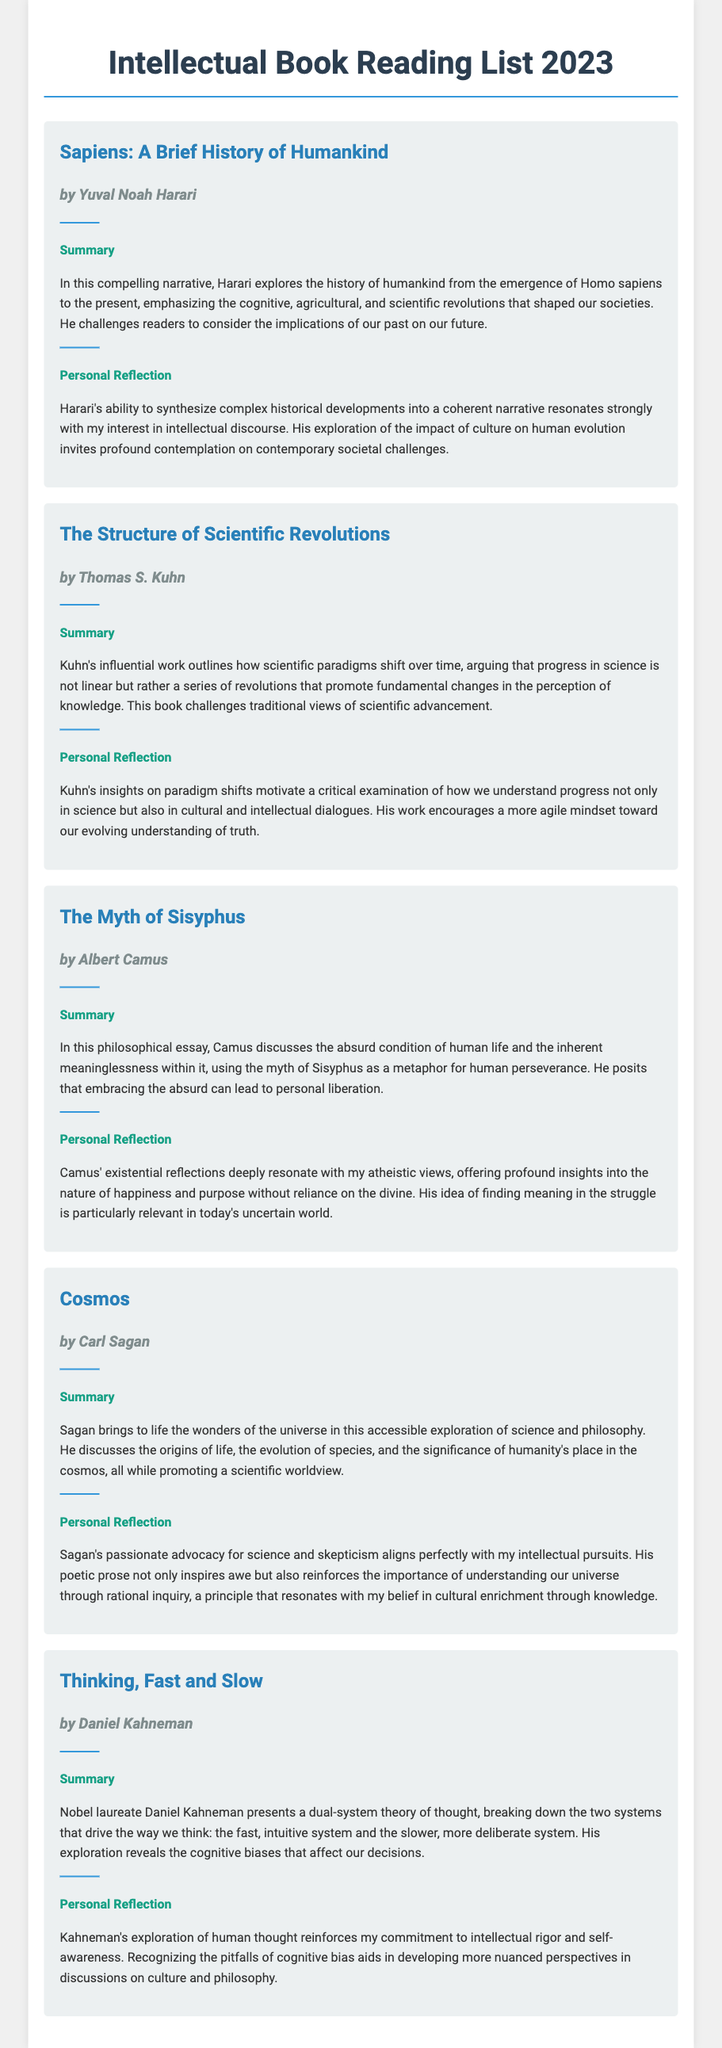What is the title of the first book? The title of the first book is the name stated in the document under the first book section.
Answer: Sapiens: A Brief History of Humankind Who is the author of "The Structure of Scientific Revolutions"? The author's name is provided in conjunction with the book title in the document.
Answer: Thomas S. Kuhn How many books are listed in the reading list? The number of books can be counted based on the sections present in the document.
Answer: 5 Which book discusses the absurd condition of human life? The content relates to the analysis provided in the summary of one of the book sections.
Answer: The Myth of Sisyphus What is the primary focus of "Cosmos"? The document explains the main themes and subjects discussed in the book summary.
Answer: Wonders of the universe What type of worldview does Carl Sagan promote in "Cosmos"? The answer can be inferred from the summary about the author's stance on scientific exploration.
Answer: Scientific worldview Which author is a Nobel laureate? The title describing the author includes a specific acknowledgment of their achievement.
Answer: Daniel Kahneman What does Kahneman explore in "Thinking, Fast and Slow"? The document elaborates on the main theme or focus discussed in the book summary.
Answer: Dual-system theory of thought 